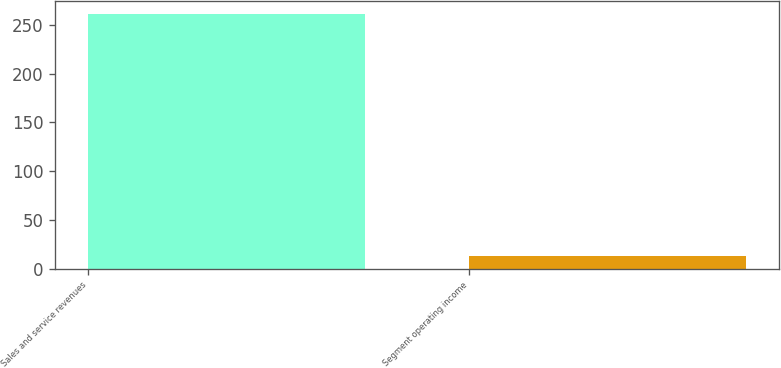Convert chart to OTSL. <chart><loc_0><loc_0><loc_500><loc_500><bar_chart><fcel>Sales and service revenues<fcel>Segment operating income<nl><fcel>261<fcel>13<nl></chart> 